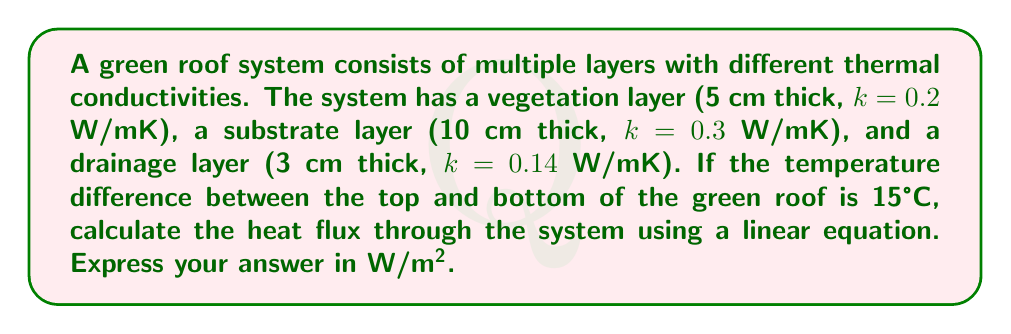Give your solution to this math problem. To solve this problem, we'll use the concept of thermal resistance and Fourier's law of heat conduction. We'll follow these steps:

1. Calculate the thermal resistance (R) of each layer:
   $R = \frac{d}{k}$, where d is thickness and k is thermal conductivity

   Vegetation layer: $R_1 = \frac{0.05}{0.2} = 0.25$ m²K/W
   Substrate layer: $R_2 = \frac{0.10}{0.3} = 0.333$ m²K/W
   Drainage layer: $R_3 = \frac{0.03}{0.14} = 0.214$ m²K/W

2. Calculate the total thermal resistance:
   $R_{total} = R_1 + R_2 + R_3 = 0.25 + 0.333 + 0.214 = 0.797$ m²K/W

3. Use the linear equation for heat flux:
   $q = \frac{\Delta T}{R_{total}}$

   Where:
   $q$ is the heat flux (W/m²)
   $\Delta T$ is the temperature difference (15°C)
   $R_{total}$ is the total thermal resistance (0.797 m²K/W)

4. Substitute the values into the equation:
   $q = \frac{15}{0.797} = 18.82$ W/m²

Therefore, the heat flux through the green roof system is approximately 18.82 W/m².
Answer: 18.82 W/m² 